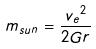<formula> <loc_0><loc_0><loc_500><loc_500>m _ { s u n } = \frac { { v _ { e } } ^ { 2 } } { 2 G r }</formula> 